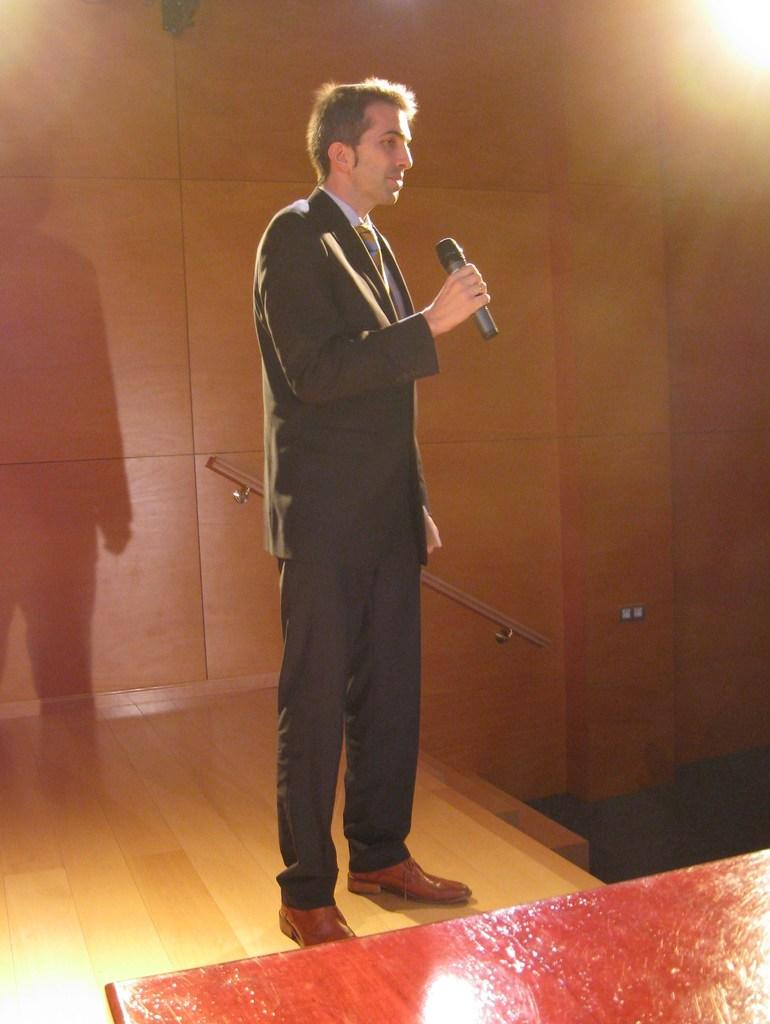What is the main subject of the image? The main subject of the image is a man. What is the man doing in the image? The man is standing in the image. What object is the man holding in his hand? The man is holding a microphone in his hand. What type of sock is the man wearing in the image? There is no information about the man's socks in the image, so it cannot be determined. 